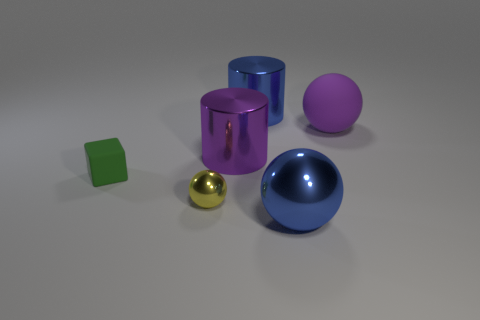Subtract all large spheres. How many spheres are left? 1 Add 1 large purple cylinders. How many objects exist? 7 Subtract all yellow balls. How many balls are left? 2 Subtract all cubes. How many objects are left? 5 Subtract all blue blocks. Subtract all red cylinders. How many blocks are left? 1 Subtract all blue cubes. How many brown cylinders are left? 0 Subtract all brown cylinders. Subtract all purple rubber spheres. How many objects are left? 5 Add 2 purple shiny objects. How many purple shiny objects are left? 3 Add 3 green blocks. How many green blocks exist? 4 Subtract 0 blue cubes. How many objects are left? 6 